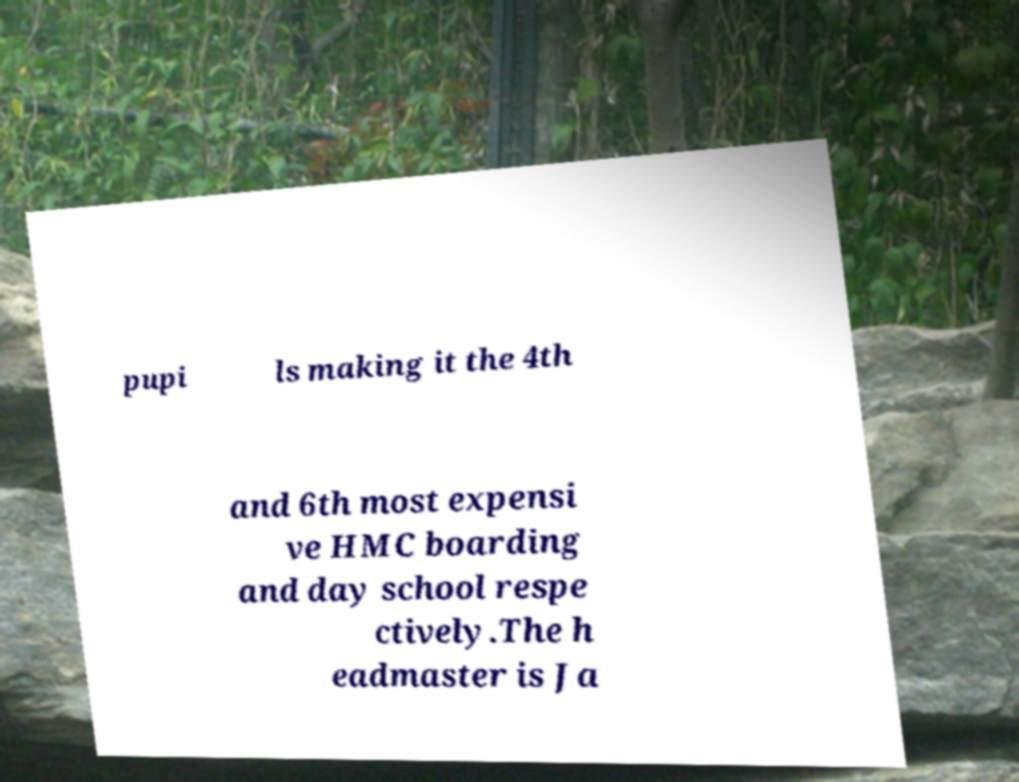There's text embedded in this image that I need extracted. Can you transcribe it verbatim? pupi ls making it the 4th and 6th most expensi ve HMC boarding and day school respe ctively.The h eadmaster is Ja 